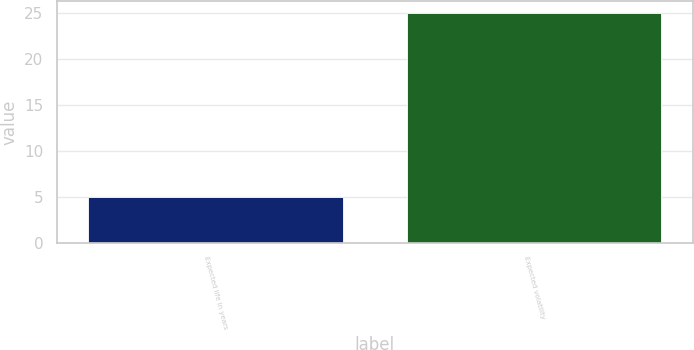Convert chart. <chart><loc_0><loc_0><loc_500><loc_500><bar_chart><fcel>Expected life in years<fcel>Expected volatility<nl><fcel>5<fcel>25<nl></chart> 